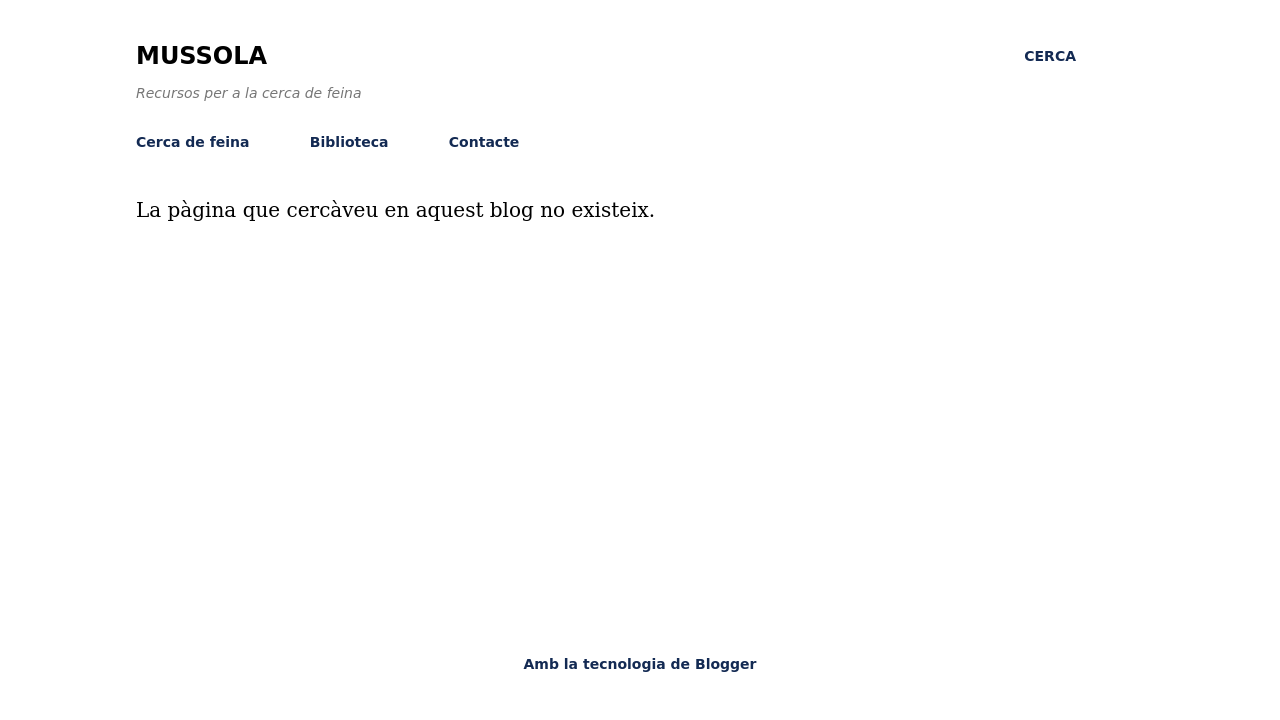Could you explain the navigation bar design on this website? Absolutely! The navigation bar on this website is minimalistic, featuring straightforward links that lead to different sections: 'Cerca de feina', 'Biblioteca', and 'Contacte'. Each link is probably styled using CSS to appear as they do in the image—simple and unadorned. Typically, this can be achieved using basic HTML for structure and applying CSS styles for visuals like font size, color, and hover effects to enhance interactivity. 